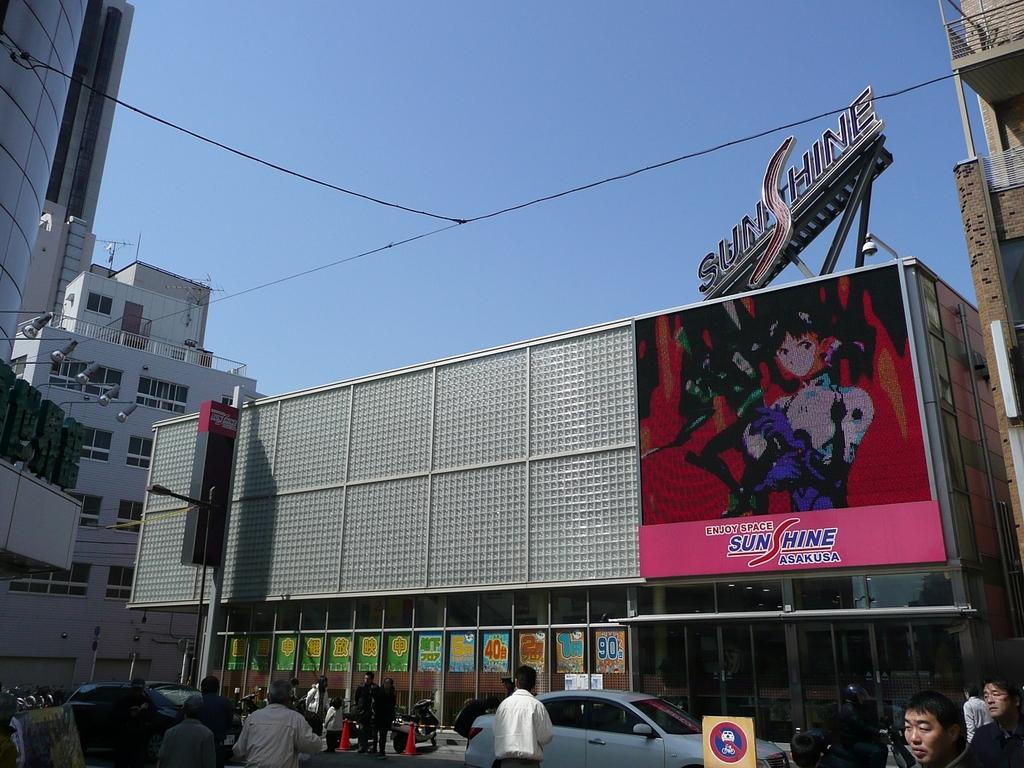<image>
Write a terse but informative summary of the picture. The ad on the side of the building is for Sunshine Asakusa 